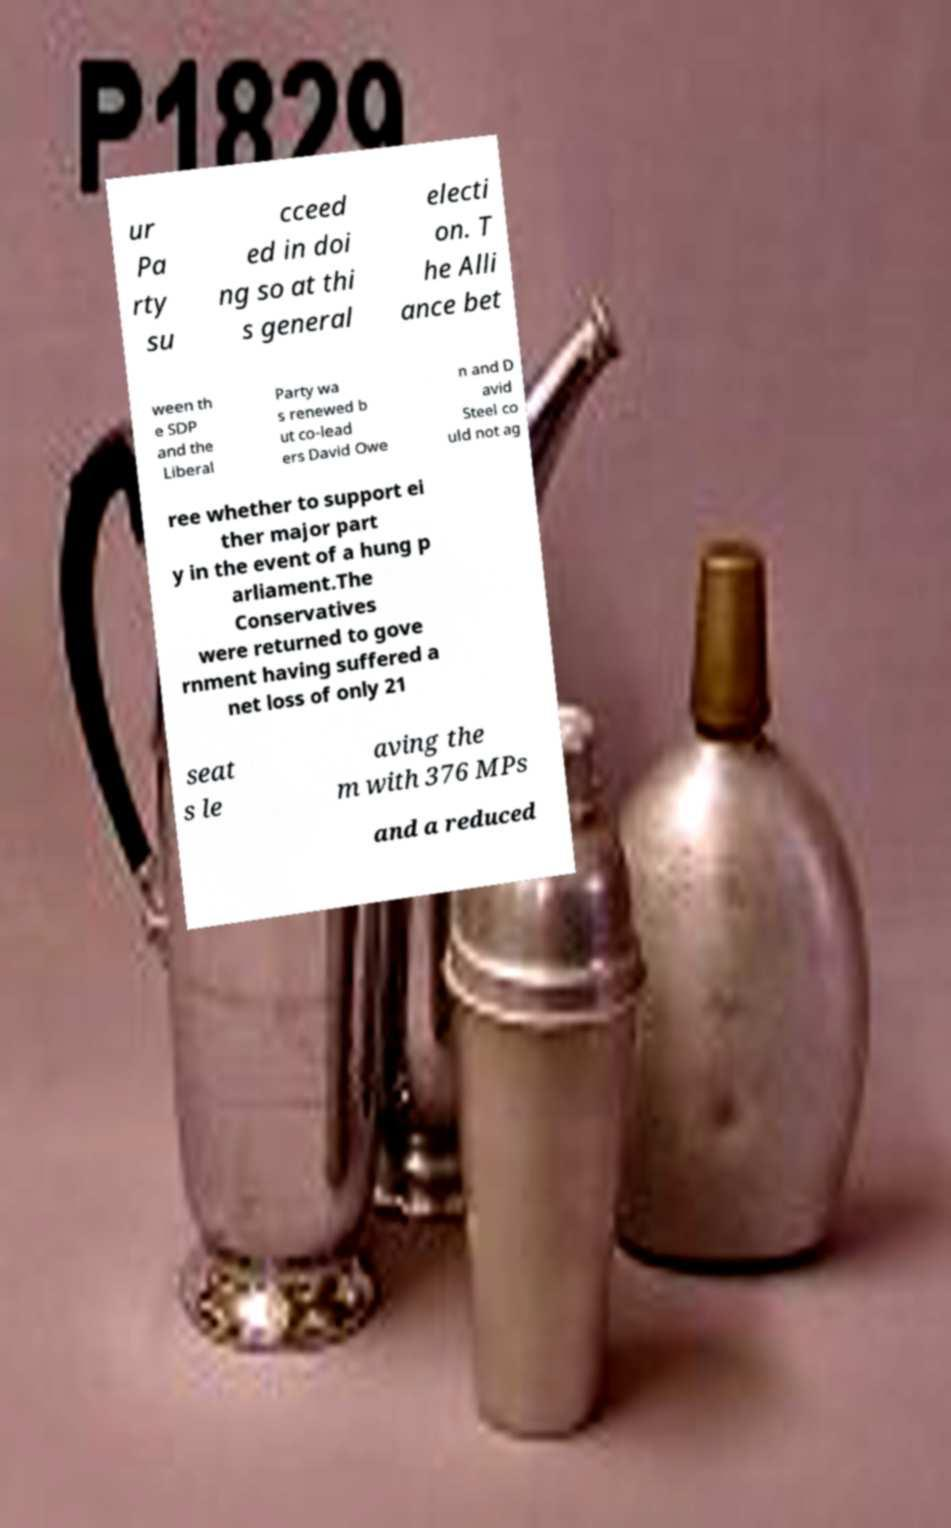Can you accurately transcribe the text from the provided image for me? ur Pa rty su cceed ed in doi ng so at thi s general electi on. T he Alli ance bet ween th e SDP and the Liberal Party wa s renewed b ut co-lead ers David Owe n and D avid Steel co uld not ag ree whether to support ei ther major part y in the event of a hung p arliament.The Conservatives were returned to gove rnment having suffered a net loss of only 21 seat s le aving the m with 376 MPs and a reduced 